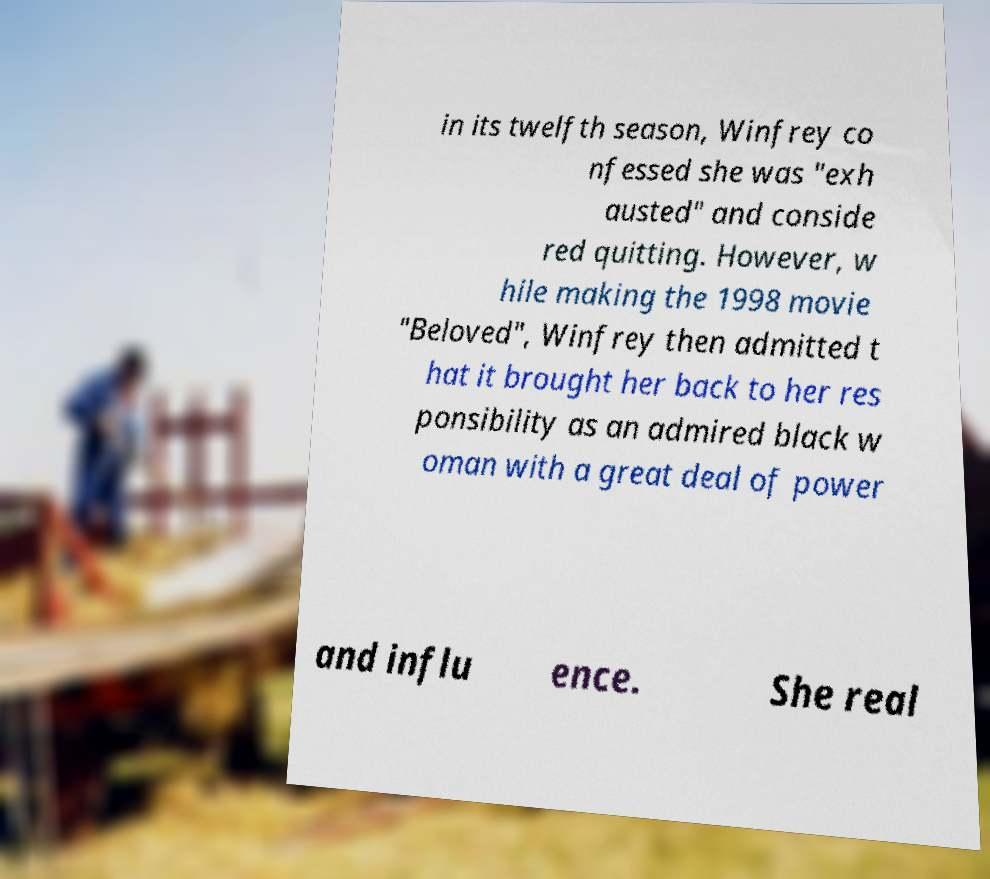Can you accurately transcribe the text from the provided image for me? in its twelfth season, Winfrey co nfessed she was "exh austed" and conside red quitting. However, w hile making the 1998 movie "Beloved", Winfrey then admitted t hat it brought her back to her res ponsibility as an admired black w oman with a great deal of power and influ ence. She real 